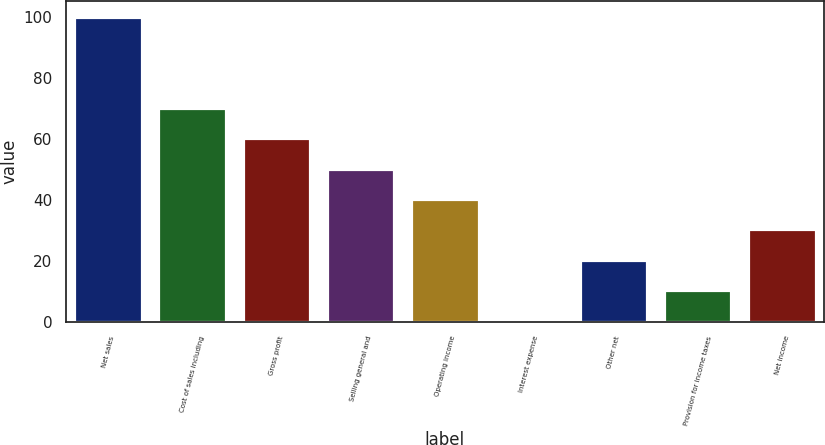Convert chart. <chart><loc_0><loc_0><loc_500><loc_500><bar_chart><fcel>Net sales<fcel>Cost of sales including<fcel>Gross profit<fcel>Selling general and<fcel>Operating income<fcel>Interest expense<fcel>Other net<fcel>Provision for income taxes<fcel>Net income<nl><fcel>100<fcel>70.15<fcel>60.2<fcel>50.25<fcel>40.3<fcel>0.5<fcel>20.4<fcel>10.45<fcel>30.35<nl></chart> 